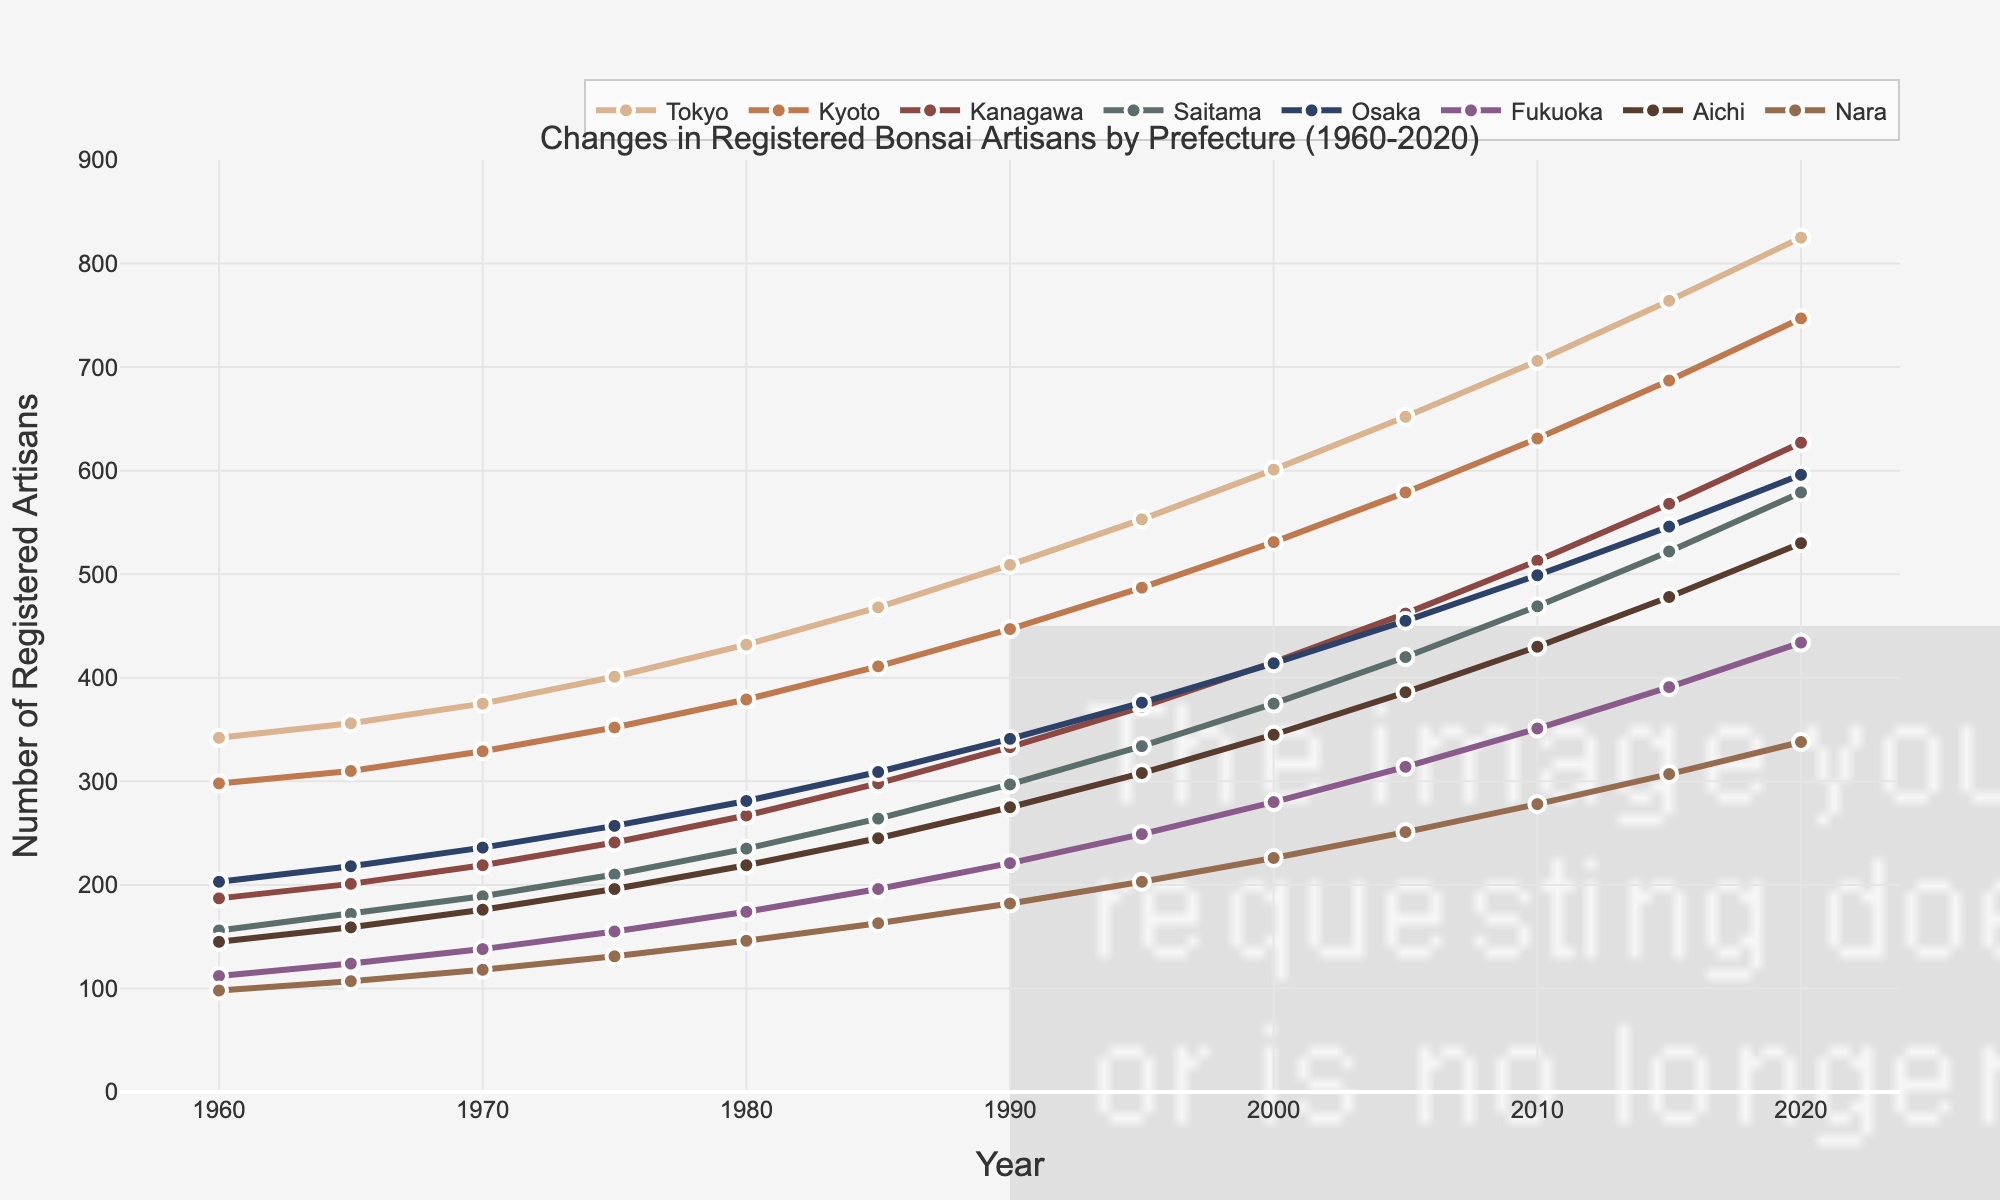What's the overall trend in the number of registered bonsai artisans in Tokyo from 1960 to 2020? The figure shows the number of registered bonsai artisans in Tokyo increasing from 342 in 1960 to 825 in 2020. By visually inspecting the line's upward slope, we can see a consistent increase over the years.
Answer: Increasing Which prefecture had the highest number of registered bonsai artisans in 2020? By comparing the heights of the lines at the 2020 mark, the line representing Tokyo is the highest, indicating it has the most artisans.
Answer: Tokyo Did Saitama ever surpass Kyoto in the number of registered bonsai artisans between 1960 and 2020? By visually comparing the lines for Saitama and Kyoto, Saitama's line is consistently below Kyoto's from 1960 to 2020, indicating Saitama never surpassed Kyoto.
Answer: No How much did the number of registered bonsai artisans in Osaka increase from 1960 to 2020? The number of registered bonsai artisans in Osaka in 1960 was 203 and increased to 596 in 2020. The increase is calculated as 596 - 203 = 393.
Answer: 393 Which prefecture showed the least increase in registered bonsai artisans from 1960 to 2020? Comparing the differences in the heights of lines from 1960 to 2020, Nara shows the least increase: from 98 in 1960 to 338 in 2020, an increase of 240 which is the smallest among the prefectures.
Answer: Nara In which decade did Tokyo see the largest increase in the number of registered bonsai artisans? By checking the slopes of Tokyo's line for each decade, the steepest area appears between 2010 and 2020, showing the largest increase. This can be estimated as 825 - 764 = 61.
Answer: 2010s What is the difference in the number of registered bonsai artisans between the prefecture with the most and the least artisans in 2020? In 2020, Tokyo has the most artisans (825) and Nara the least (338). The difference is calculated as 825 - 338 = 487.
Answer: 487 What was the average number of registered bonsai artisans in Kanagawa in the decades shown? Calculate the average of Kanagawa's values across the years: (187 + 201 + 219 + 241 + 267 + 298 + 333 + 372 + 415 + 462 + 513 + 568 + 627) / 13 ≈ 364.
Answer: 364 Have any prefectures' number of registered bonsai artisans remained the same for any given consecutive years? Upon visual inspection, no lines appear perfectly horizontal for any pairs of consecutive years; hence, no prefectures maintained the same number from one data point to the next.
Answer: No 